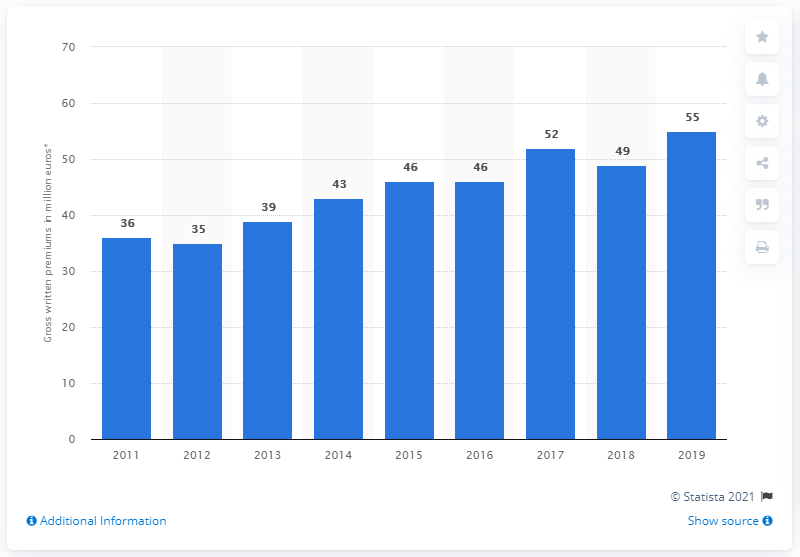Indicate a few pertinent items in this graphic. The total amount of premiums written in Latvia in 2019 was 55. 